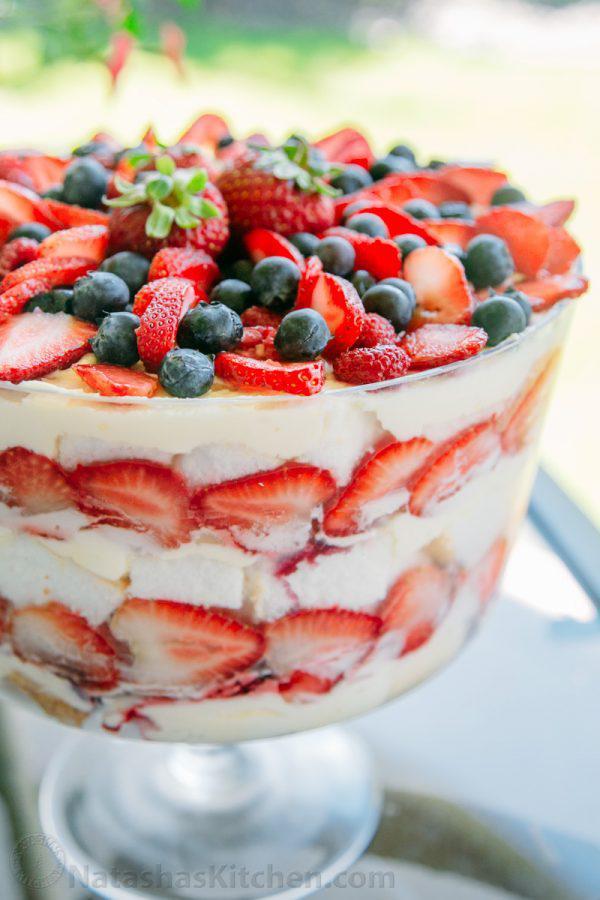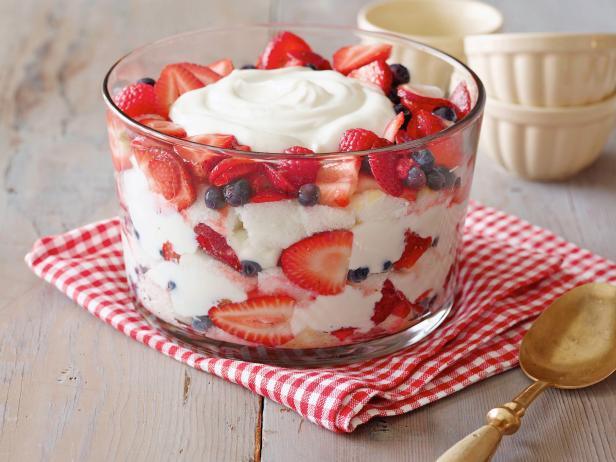The first image is the image on the left, the second image is the image on the right. Given the left and right images, does the statement "The dessert is sitting on a folded red and white cloth in one image." hold true? Answer yes or no. Yes. The first image is the image on the left, the second image is the image on the right. Considering the images on both sides, is "Two large fancy layered desserts are made with sliced strawberries." valid? Answer yes or no. Yes. 